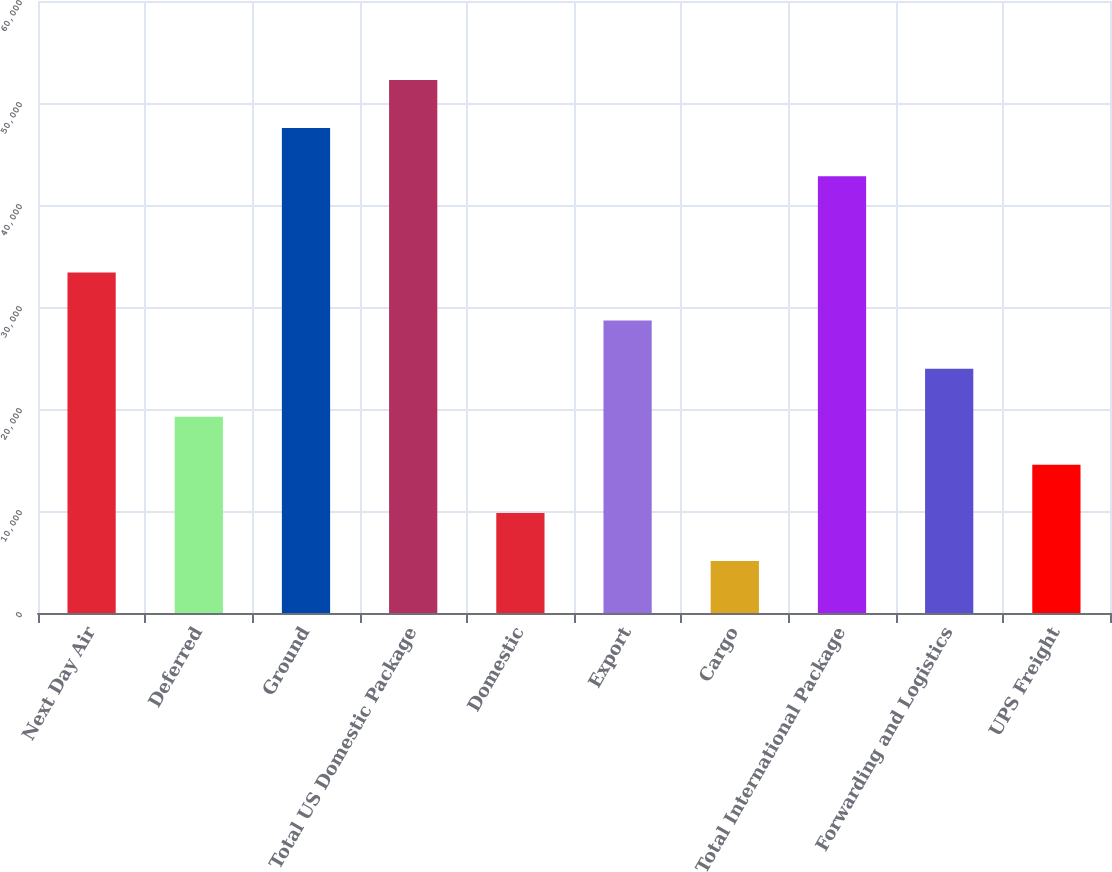<chart> <loc_0><loc_0><loc_500><loc_500><bar_chart><fcel>Next Day Air<fcel>Deferred<fcel>Ground<fcel>Total US Domestic Package<fcel>Domestic<fcel>Export<fcel>Cargo<fcel>Total International Package<fcel>Forwarding and Logistics<fcel>UPS Freight<nl><fcel>33393.6<fcel>19240.2<fcel>47547<fcel>52264.8<fcel>9804.6<fcel>28675.8<fcel>5086.8<fcel>42829.2<fcel>23958<fcel>14522.4<nl></chart> 